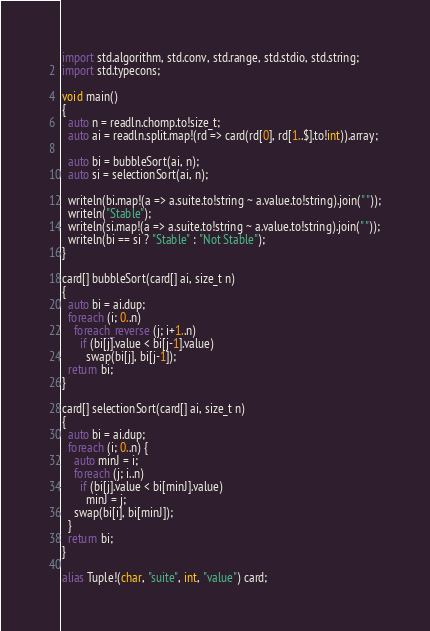<code> <loc_0><loc_0><loc_500><loc_500><_D_>import std.algorithm, std.conv, std.range, std.stdio, std.string;
import std.typecons;

void main()
{
  auto n = readln.chomp.to!size_t;
  auto ai = readln.split.map!(rd => card(rd[0], rd[1..$].to!int)).array;

  auto bi = bubbleSort(ai, n);
  auto si = selectionSort(ai, n);

  writeln(bi.map!(a => a.suite.to!string ~ a.value.to!string).join(" "));
  writeln("Stable");
  writeln(si.map!(a => a.suite.to!string ~ a.value.to!string).join(" "));
  writeln(bi == si ? "Stable" : "Not Stable");
}

card[] bubbleSort(card[] ai, size_t n)
{
  auto bi = ai.dup;
  foreach (i; 0..n)
    foreach_reverse (j; i+1..n)
      if (bi[j].value < bi[j-1].value)
        swap(bi[j], bi[j-1]);
  return bi;
}

card[] selectionSort(card[] ai, size_t n)
{
  auto bi = ai.dup;
  foreach (i; 0..n) {
    auto minJ = i;
    foreach (j; i..n)
      if (bi[j].value < bi[minJ].value)
        minJ = j;
    swap(bi[i], bi[minJ]);
  }
  return bi;
}

alias Tuple!(char, "suite", int, "value") card;</code> 